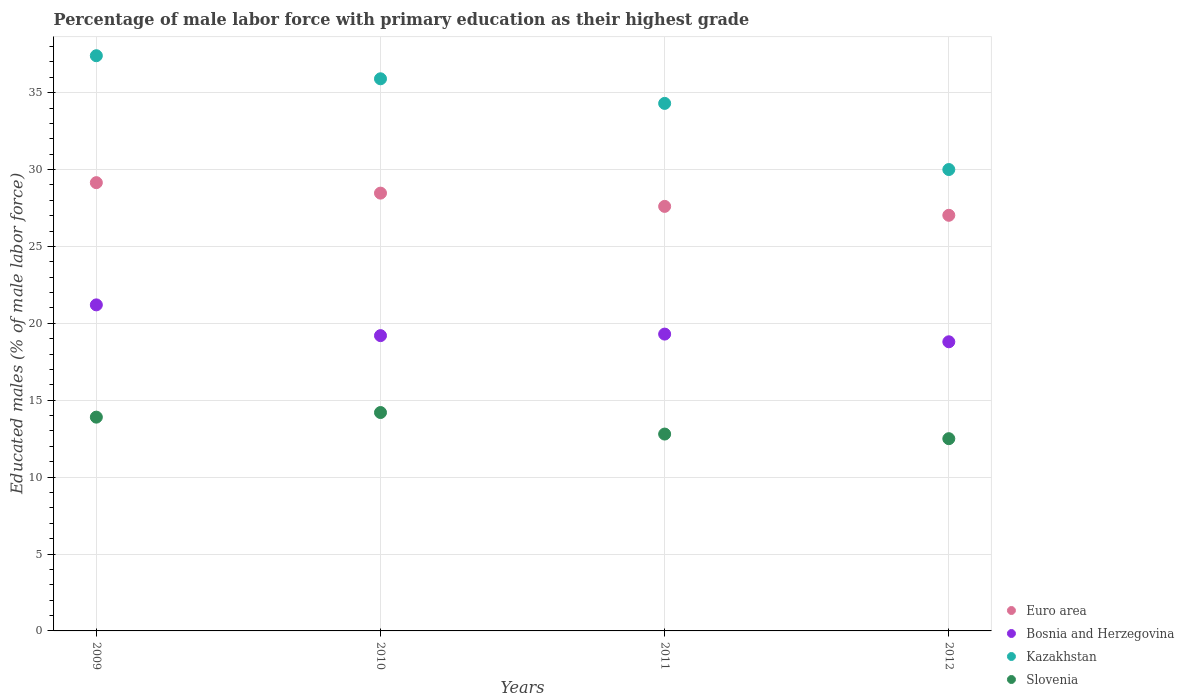How many different coloured dotlines are there?
Give a very brief answer. 4. Is the number of dotlines equal to the number of legend labels?
Offer a terse response. Yes. What is the percentage of male labor force with primary education in Bosnia and Herzegovina in 2010?
Provide a short and direct response. 19.2. Across all years, what is the maximum percentage of male labor force with primary education in Slovenia?
Provide a succinct answer. 14.2. Across all years, what is the minimum percentage of male labor force with primary education in Kazakhstan?
Provide a short and direct response. 30. In which year was the percentage of male labor force with primary education in Euro area minimum?
Your answer should be compact. 2012. What is the total percentage of male labor force with primary education in Kazakhstan in the graph?
Provide a short and direct response. 137.6. What is the difference between the percentage of male labor force with primary education in Slovenia in 2011 and the percentage of male labor force with primary education in Euro area in 2010?
Provide a short and direct response. -15.67. What is the average percentage of male labor force with primary education in Kazakhstan per year?
Make the answer very short. 34.4. In the year 2011, what is the difference between the percentage of male labor force with primary education in Kazakhstan and percentage of male labor force with primary education in Euro area?
Make the answer very short. 6.7. In how many years, is the percentage of male labor force with primary education in Bosnia and Herzegovina greater than 23 %?
Offer a very short reply. 0. What is the ratio of the percentage of male labor force with primary education in Bosnia and Herzegovina in 2010 to that in 2012?
Provide a succinct answer. 1.02. Is the difference between the percentage of male labor force with primary education in Kazakhstan in 2011 and 2012 greater than the difference between the percentage of male labor force with primary education in Euro area in 2011 and 2012?
Keep it short and to the point. Yes. What is the difference between the highest and the second highest percentage of male labor force with primary education in Bosnia and Herzegovina?
Offer a very short reply. 1.9. What is the difference between the highest and the lowest percentage of male labor force with primary education in Bosnia and Herzegovina?
Your response must be concise. 2.4. Is the sum of the percentage of male labor force with primary education in Euro area in 2010 and 2012 greater than the maximum percentage of male labor force with primary education in Bosnia and Herzegovina across all years?
Your answer should be very brief. Yes. Is the percentage of male labor force with primary education in Euro area strictly less than the percentage of male labor force with primary education in Kazakhstan over the years?
Provide a short and direct response. Yes. How many dotlines are there?
Your response must be concise. 4. How many years are there in the graph?
Your response must be concise. 4. What is the difference between two consecutive major ticks on the Y-axis?
Ensure brevity in your answer.  5. Are the values on the major ticks of Y-axis written in scientific E-notation?
Your answer should be very brief. No. Does the graph contain grids?
Offer a terse response. Yes. How are the legend labels stacked?
Ensure brevity in your answer.  Vertical. What is the title of the graph?
Give a very brief answer. Percentage of male labor force with primary education as their highest grade. Does "Latvia" appear as one of the legend labels in the graph?
Provide a short and direct response. No. What is the label or title of the X-axis?
Your answer should be very brief. Years. What is the label or title of the Y-axis?
Your response must be concise. Educated males (% of male labor force). What is the Educated males (% of male labor force) of Euro area in 2009?
Offer a terse response. 29.15. What is the Educated males (% of male labor force) of Bosnia and Herzegovina in 2009?
Make the answer very short. 21.2. What is the Educated males (% of male labor force) of Kazakhstan in 2009?
Make the answer very short. 37.4. What is the Educated males (% of male labor force) in Slovenia in 2009?
Give a very brief answer. 13.9. What is the Educated males (% of male labor force) in Euro area in 2010?
Give a very brief answer. 28.47. What is the Educated males (% of male labor force) of Bosnia and Herzegovina in 2010?
Ensure brevity in your answer.  19.2. What is the Educated males (% of male labor force) in Kazakhstan in 2010?
Give a very brief answer. 35.9. What is the Educated males (% of male labor force) of Slovenia in 2010?
Provide a short and direct response. 14.2. What is the Educated males (% of male labor force) in Euro area in 2011?
Ensure brevity in your answer.  27.6. What is the Educated males (% of male labor force) in Bosnia and Herzegovina in 2011?
Your response must be concise. 19.3. What is the Educated males (% of male labor force) of Kazakhstan in 2011?
Offer a very short reply. 34.3. What is the Educated males (% of male labor force) in Slovenia in 2011?
Give a very brief answer. 12.8. What is the Educated males (% of male labor force) of Euro area in 2012?
Your answer should be compact. 27.02. What is the Educated males (% of male labor force) in Bosnia and Herzegovina in 2012?
Your answer should be compact. 18.8. What is the Educated males (% of male labor force) of Kazakhstan in 2012?
Your answer should be very brief. 30. Across all years, what is the maximum Educated males (% of male labor force) in Euro area?
Make the answer very short. 29.15. Across all years, what is the maximum Educated males (% of male labor force) in Bosnia and Herzegovina?
Make the answer very short. 21.2. Across all years, what is the maximum Educated males (% of male labor force) of Kazakhstan?
Make the answer very short. 37.4. Across all years, what is the maximum Educated males (% of male labor force) in Slovenia?
Keep it short and to the point. 14.2. Across all years, what is the minimum Educated males (% of male labor force) in Euro area?
Your answer should be compact. 27.02. Across all years, what is the minimum Educated males (% of male labor force) of Bosnia and Herzegovina?
Give a very brief answer. 18.8. What is the total Educated males (% of male labor force) of Euro area in the graph?
Provide a short and direct response. 112.24. What is the total Educated males (% of male labor force) of Bosnia and Herzegovina in the graph?
Provide a succinct answer. 78.5. What is the total Educated males (% of male labor force) in Kazakhstan in the graph?
Ensure brevity in your answer.  137.6. What is the total Educated males (% of male labor force) in Slovenia in the graph?
Make the answer very short. 53.4. What is the difference between the Educated males (% of male labor force) in Euro area in 2009 and that in 2010?
Your answer should be very brief. 0.68. What is the difference between the Educated males (% of male labor force) in Slovenia in 2009 and that in 2010?
Keep it short and to the point. -0.3. What is the difference between the Educated males (% of male labor force) in Euro area in 2009 and that in 2011?
Keep it short and to the point. 1.54. What is the difference between the Educated males (% of male labor force) of Kazakhstan in 2009 and that in 2011?
Keep it short and to the point. 3.1. What is the difference between the Educated males (% of male labor force) in Slovenia in 2009 and that in 2011?
Your response must be concise. 1.1. What is the difference between the Educated males (% of male labor force) in Euro area in 2009 and that in 2012?
Ensure brevity in your answer.  2.12. What is the difference between the Educated males (% of male labor force) in Bosnia and Herzegovina in 2009 and that in 2012?
Make the answer very short. 2.4. What is the difference between the Educated males (% of male labor force) of Kazakhstan in 2009 and that in 2012?
Offer a very short reply. 7.4. What is the difference between the Educated males (% of male labor force) of Euro area in 2010 and that in 2011?
Your answer should be compact. 0.86. What is the difference between the Educated males (% of male labor force) of Euro area in 2010 and that in 2012?
Offer a very short reply. 1.44. What is the difference between the Educated males (% of male labor force) of Slovenia in 2010 and that in 2012?
Make the answer very short. 1.7. What is the difference between the Educated males (% of male labor force) in Euro area in 2011 and that in 2012?
Provide a succinct answer. 0.58. What is the difference between the Educated males (% of male labor force) of Bosnia and Herzegovina in 2011 and that in 2012?
Keep it short and to the point. 0.5. What is the difference between the Educated males (% of male labor force) in Kazakhstan in 2011 and that in 2012?
Ensure brevity in your answer.  4.3. What is the difference between the Educated males (% of male labor force) of Slovenia in 2011 and that in 2012?
Offer a terse response. 0.3. What is the difference between the Educated males (% of male labor force) of Euro area in 2009 and the Educated males (% of male labor force) of Bosnia and Herzegovina in 2010?
Give a very brief answer. 9.95. What is the difference between the Educated males (% of male labor force) of Euro area in 2009 and the Educated males (% of male labor force) of Kazakhstan in 2010?
Offer a very short reply. -6.75. What is the difference between the Educated males (% of male labor force) of Euro area in 2009 and the Educated males (% of male labor force) of Slovenia in 2010?
Make the answer very short. 14.95. What is the difference between the Educated males (% of male labor force) in Bosnia and Herzegovina in 2009 and the Educated males (% of male labor force) in Kazakhstan in 2010?
Your response must be concise. -14.7. What is the difference between the Educated males (% of male labor force) in Kazakhstan in 2009 and the Educated males (% of male labor force) in Slovenia in 2010?
Your answer should be compact. 23.2. What is the difference between the Educated males (% of male labor force) in Euro area in 2009 and the Educated males (% of male labor force) in Bosnia and Herzegovina in 2011?
Offer a terse response. 9.85. What is the difference between the Educated males (% of male labor force) in Euro area in 2009 and the Educated males (% of male labor force) in Kazakhstan in 2011?
Your answer should be very brief. -5.15. What is the difference between the Educated males (% of male labor force) of Euro area in 2009 and the Educated males (% of male labor force) of Slovenia in 2011?
Your response must be concise. 16.35. What is the difference between the Educated males (% of male labor force) of Bosnia and Herzegovina in 2009 and the Educated males (% of male labor force) of Slovenia in 2011?
Provide a short and direct response. 8.4. What is the difference between the Educated males (% of male labor force) of Kazakhstan in 2009 and the Educated males (% of male labor force) of Slovenia in 2011?
Offer a very short reply. 24.6. What is the difference between the Educated males (% of male labor force) of Euro area in 2009 and the Educated males (% of male labor force) of Bosnia and Herzegovina in 2012?
Your answer should be very brief. 10.35. What is the difference between the Educated males (% of male labor force) of Euro area in 2009 and the Educated males (% of male labor force) of Kazakhstan in 2012?
Give a very brief answer. -0.85. What is the difference between the Educated males (% of male labor force) in Euro area in 2009 and the Educated males (% of male labor force) in Slovenia in 2012?
Make the answer very short. 16.65. What is the difference between the Educated males (% of male labor force) of Bosnia and Herzegovina in 2009 and the Educated males (% of male labor force) of Kazakhstan in 2012?
Give a very brief answer. -8.8. What is the difference between the Educated males (% of male labor force) in Kazakhstan in 2009 and the Educated males (% of male labor force) in Slovenia in 2012?
Give a very brief answer. 24.9. What is the difference between the Educated males (% of male labor force) in Euro area in 2010 and the Educated males (% of male labor force) in Bosnia and Herzegovina in 2011?
Your response must be concise. 9.17. What is the difference between the Educated males (% of male labor force) in Euro area in 2010 and the Educated males (% of male labor force) in Kazakhstan in 2011?
Your answer should be very brief. -5.83. What is the difference between the Educated males (% of male labor force) in Euro area in 2010 and the Educated males (% of male labor force) in Slovenia in 2011?
Your answer should be compact. 15.67. What is the difference between the Educated males (% of male labor force) of Bosnia and Herzegovina in 2010 and the Educated males (% of male labor force) of Kazakhstan in 2011?
Your answer should be compact. -15.1. What is the difference between the Educated males (% of male labor force) of Bosnia and Herzegovina in 2010 and the Educated males (% of male labor force) of Slovenia in 2011?
Your answer should be compact. 6.4. What is the difference between the Educated males (% of male labor force) of Kazakhstan in 2010 and the Educated males (% of male labor force) of Slovenia in 2011?
Offer a very short reply. 23.1. What is the difference between the Educated males (% of male labor force) of Euro area in 2010 and the Educated males (% of male labor force) of Bosnia and Herzegovina in 2012?
Provide a short and direct response. 9.67. What is the difference between the Educated males (% of male labor force) of Euro area in 2010 and the Educated males (% of male labor force) of Kazakhstan in 2012?
Your response must be concise. -1.53. What is the difference between the Educated males (% of male labor force) of Euro area in 2010 and the Educated males (% of male labor force) of Slovenia in 2012?
Offer a terse response. 15.97. What is the difference between the Educated males (% of male labor force) in Bosnia and Herzegovina in 2010 and the Educated males (% of male labor force) in Kazakhstan in 2012?
Offer a terse response. -10.8. What is the difference between the Educated males (% of male labor force) in Kazakhstan in 2010 and the Educated males (% of male labor force) in Slovenia in 2012?
Provide a succinct answer. 23.4. What is the difference between the Educated males (% of male labor force) of Euro area in 2011 and the Educated males (% of male labor force) of Bosnia and Herzegovina in 2012?
Give a very brief answer. 8.8. What is the difference between the Educated males (% of male labor force) in Euro area in 2011 and the Educated males (% of male labor force) in Kazakhstan in 2012?
Give a very brief answer. -2.4. What is the difference between the Educated males (% of male labor force) of Euro area in 2011 and the Educated males (% of male labor force) of Slovenia in 2012?
Offer a very short reply. 15.1. What is the difference between the Educated males (% of male labor force) in Bosnia and Herzegovina in 2011 and the Educated males (% of male labor force) in Slovenia in 2012?
Keep it short and to the point. 6.8. What is the difference between the Educated males (% of male labor force) in Kazakhstan in 2011 and the Educated males (% of male labor force) in Slovenia in 2012?
Ensure brevity in your answer.  21.8. What is the average Educated males (% of male labor force) of Euro area per year?
Keep it short and to the point. 28.06. What is the average Educated males (% of male labor force) of Bosnia and Herzegovina per year?
Ensure brevity in your answer.  19.62. What is the average Educated males (% of male labor force) in Kazakhstan per year?
Give a very brief answer. 34.4. What is the average Educated males (% of male labor force) of Slovenia per year?
Your answer should be compact. 13.35. In the year 2009, what is the difference between the Educated males (% of male labor force) of Euro area and Educated males (% of male labor force) of Bosnia and Herzegovina?
Keep it short and to the point. 7.95. In the year 2009, what is the difference between the Educated males (% of male labor force) of Euro area and Educated males (% of male labor force) of Kazakhstan?
Your answer should be compact. -8.25. In the year 2009, what is the difference between the Educated males (% of male labor force) of Euro area and Educated males (% of male labor force) of Slovenia?
Your response must be concise. 15.25. In the year 2009, what is the difference between the Educated males (% of male labor force) in Bosnia and Herzegovina and Educated males (% of male labor force) in Kazakhstan?
Offer a very short reply. -16.2. In the year 2009, what is the difference between the Educated males (% of male labor force) in Bosnia and Herzegovina and Educated males (% of male labor force) in Slovenia?
Provide a short and direct response. 7.3. In the year 2010, what is the difference between the Educated males (% of male labor force) in Euro area and Educated males (% of male labor force) in Bosnia and Herzegovina?
Keep it short and to the point. 9.27. In the year 2010, what is the difference between the Educated males (% of male labor force) of Euro area and Educated males (% of male labor force) of Kazakhstan?
Make the answer very short. -7.43. In the year 2010, what is the difference between the Educated males (% of male labor force) of Euro area and Educated males (% of male labor force) of Slovenia?
Ensure brevity in your answer.  14.27. In the year 2010, what is the difference between the Educated males (% of male labor force) in Bosnia and Herzegovina and Educated males (% of male labor force) in Kazakhstan?
Offer a terse response. -16.7. In the year 2010, what is the difference between the Educated males (% of male labor force) of Kazakhstan and Educated males (% of male labor force) of Slovenia?
Provide a succinct answer. 21.7. In the year 2011, what is the difference between the Educated males (% of male labor force) of Euro area and Educated males (% of male labor force) of Bosnia and Herzegovina?
Give a very brief answer. 8.3. In the year 2011, what is the difference between the Educated males (% of male labor force) of Euro area and Educated males (% of male labor force) of Kazakhstan?
Provide a succinct answer. -6.7. In the year 2011, what is the difference between the Educated males (% of male labor force) in Euro area and Educated males (% of male labor force) in Slovenia?
Keep it short and to the point. 14.8. In the year 2011, what is the difference between the Educated males (% of male labor force) in Bosnia and Herzegovina and Educated males (% of male labor force) in Kazakhstan?
Provide a succinct answer. -15. In the year 2011, what is the difference between the Educated males (% of male labor force) in Bosnia and Herzegovina and Educated males (% of male labor force) in Slovenia?
Give a very brief answer. 6.5. In the year 2012, what is the difference between the Educated males (% of male labor force) in Euro area and Educated males (% of male labor force) in Bosnia and Herzegovina?
Give a very brief answer. 8.22. In the year 2012, what is the difference between the Educated males (% of male labor force) of Euro area and Educated males (% of male labor force) of Kazakhstan?
Offer a very short reply. -2.98. In the year 2012, what is the difference between the Educated males (% of male labor force) in Euro area and Educated males (% of male labor force) in Slovenia?
Offer a terse response. 14.52. In the year 2012, what is the difference between the Educated males (% of male labor force) in Bosnia and Herzegovina and Educated males (% of male labor force) in Slovenia?
Give a very brief answer. 6.3. What is the ratio of the Educated males (% of male labor force) in Euro area in 2009 to that in 2010?
Your answer should be very brief. 1.02. What is the ratio of the Educated males (% of male labor force) of Bosnia and Herzegovina in 2009 to that in 2010?
Offer a very short reply. 1.1. What is the ratio of the Educated males (% of male labor force) of Kazakhstan in 2009 to that in 2010?
Your answer should be compact. 1.04. What is the ratio of the Educated males (% of male labor force) in Slovenia in 2009 to that in 2010?
Keep it short and to the point. 0.98. What is the ratio of the Educated males (% of male labor force) of Euro area in 2009 to that in 2011?
Your answer should be very brief. 1.06. What is the ratio of the Educated males (% of male labor force) in Bosnia and Herzegovina in 2009 to that in 2011?
Your answer should be compact. 1.1. What is the ratio of the Educated males (% of male labor force) of Kazakhstan in 2009 to that in 2011?
Ensure brevity in your answer.  1.09. What is the ratio of the Educated males (% of male labor force) of Slovenia in 2009 to that in 2011?
Provide a succinct answer. 1.09. What is the ratio of the Educated males (% of male labor force) in Euro area in 2009 to that in 2012?
Provide a short and direct response. 1.08. What is the ratio of the Educated males (% of male labor force) of Bosnia and Herzegovina in 2009 to that in 2012?
Offer a terse response. 1.13. What is the ratio of the Educated males (% of male labor force) in Kazakhstan in 2009 to that in 2012?
Your answer should be compact. 1.25. What is the ratio of the Educated males (% of male labor force) of Slovenia in 2009 to that in 2012?
Make the answer very short. 1.11. What is the ratio of the Educated males (% of male labor force) of Euro area in 2010 to that in 2011?
Provide a succinct answer. 1.03. What is the ratio of the Educated males (% of male labor force) in Kazakhstan in 2010 to that in 2011?
Provide a succinct answer. 1.05. What is the ratio of the Educated males (% of male labor force) of Slovenia in 2010 to that in 2011?
Keep it short and to the point. 1.11. What is the ratio of the Educated males (% of male labor force) of Euro area in 2010 to that in 2012?
Your answer should be very brief. 1.05. What is the ratio of the Educated males (% of male labor force) in Bosnia and Herzegovina in 2010 to that in 2012?
Offer a terse response. 1.02. What is the ratio of the Educated males (% of male labor force) in Kazakhstan in 2010 to that in 2012?
Keep it short and to the point. 1.2. What is the ratio of the Educated males (% of male labor force) in Slovenia in 2010 to that in 2012?
Offer a very short reply. 1.14. What is the ratio of the Educated males (% of male labor force) in Euro area in 2011 to that in 2012?
Make the answer very short. 1.02. What is the ratio of the Educated males (% of male labor force) of Bosnia and Herzegovina in 2011 to that in 2012?
Your answer should be compact. 1.03. What is the ratio of the Educated males (% of male labor force) of Kazakhstan in 2011 to that in 2012?
Ensure brevity in your answer.  1.14. What is the ratio of the Educated males (% of male labor force) of Slovenia in 2011 to that in 2012?
Ensure brevity in your answer.  1.02. What is the difference between the highest and the second highest Educated males (% of male labor force) in Euro area?
Your answer should be compact. 0.68. What is the difference between the highest and the second highest Educated males (% of male labor force) of Kazakhstan?
Keep it short and to the point. 1.5. What is the difference between the highest and the second highest Educated males (% of male labor force) in Slovenia?
Offer a very short reply. 0.3. What is the difference between the highest and the lowest Educated males (% of male labor force) in Euro area?
Offer a terse response. 2.12. What is the difference between the highest and the lowest Educated males (% of male labor force) of Bosnia and Herzegovina?
Give a very brief answer. 2.4. What is the difference between the highest and the lowest Educated males (% of male labor force) in Kazakhstan?
Make the answer very short. 7.4. What is the difference between the highest and the lowest Educated males (% of male labor force) of Slovenia?
Provide a short and direct response. 1.7. 